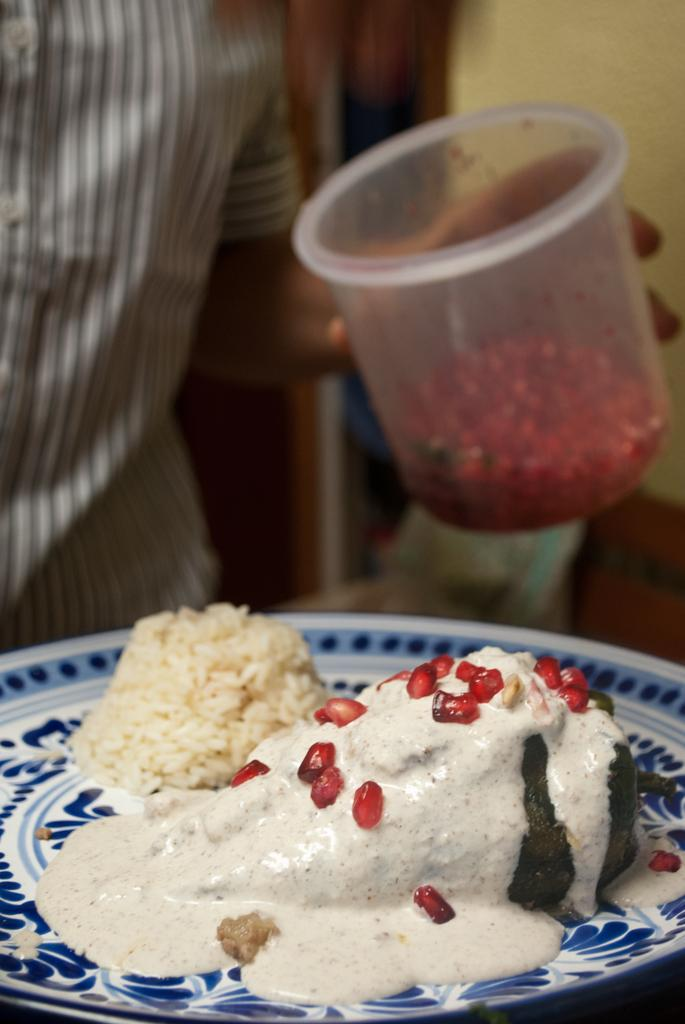What is on the plate at the bottom of the image? There is food on the plate at the bottom of the image. What is the person in the background holding? The person in the background is holding a bowl. What can be seen behind the person holding the bowl? There is a wall visible in the background of the image. What type of dress is hanging on the wall in the image? There is no dress hanging on the wall in the image; only a wall is visible in the background. 